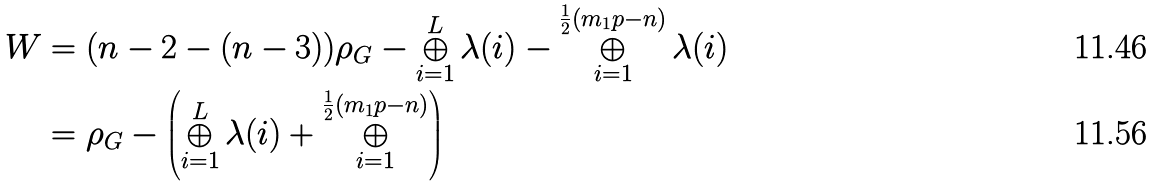<formula> <loc_0><loc_0><loc_500><loc_500>W & = ( n - 2 - ( n - 3 ) ) \rho _ { G } - \bigoplus _ { i = 1 } ^ { L } \lambda ( i ) - \bigoplus _ { i = 1 } ^ { \frac { 1 } { 2 } ( m _ { 1 } p - n ) } \lambda ( i ) \\ & = \rho _ { G } - \left ( \bigoplus _ { i = 1 } ^ { L } \lambda ( i ) + \bigoplus _ { i = 1 } ^ { \frac { 1 } { 2 } ( m _ { 1 } p - n ) } \right )</formula> 